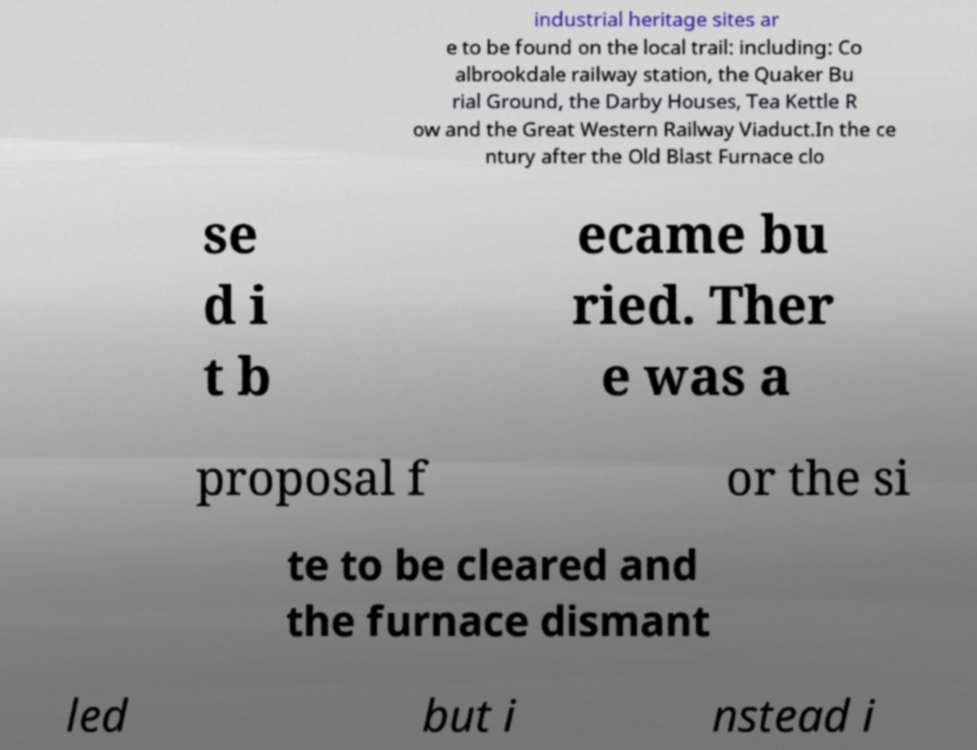Could you assist in decoding the text presented in this image and type it out clearly? industrial heritage sites ar e to be found on the local trail: including: Co albrookdale railway station, the Quaker Bu rial Ground, the Darby Houses, Tea Kettle R ow and the Great Western Railway Viaduct.In the ce ntury after the Old Blast Furnace clo se d i t b ecame bu ried. Ther e was a proposal f or the si te to be cleared and the furnace dismant led but i nstead i 